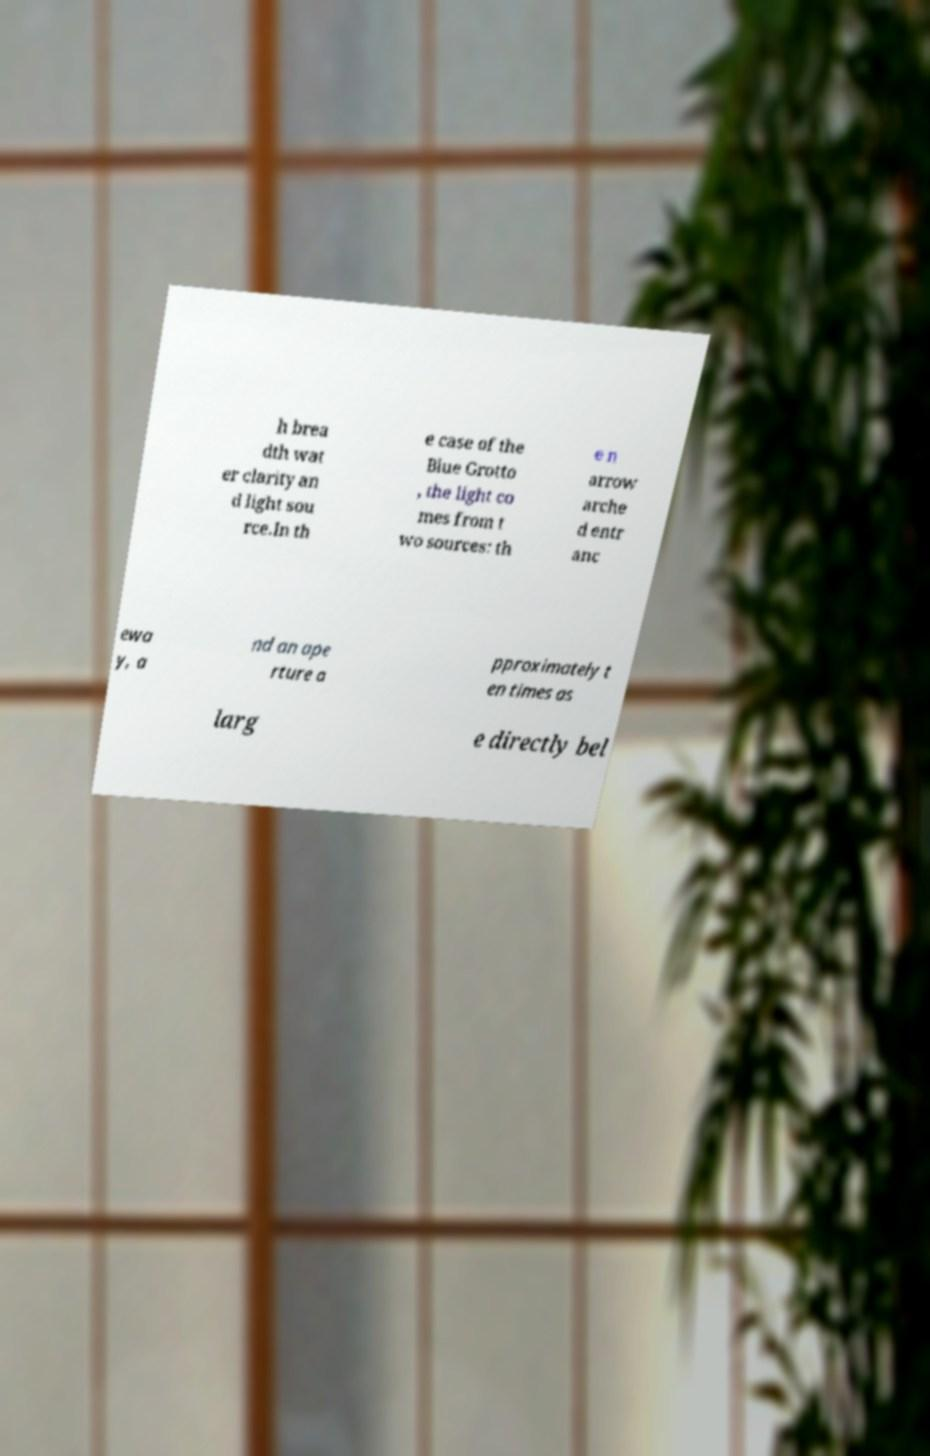For documentation purposes, I need the text within this image transcribed. Could you provide that? h brea dth wat er clarity an d light sou rce.In th e case of the Blue Grotto , the light co mes from t wo sources: th e n arrow arche d entr anc ewa y, a nd an ape rture a pproximately t en times as larg e directly bel 